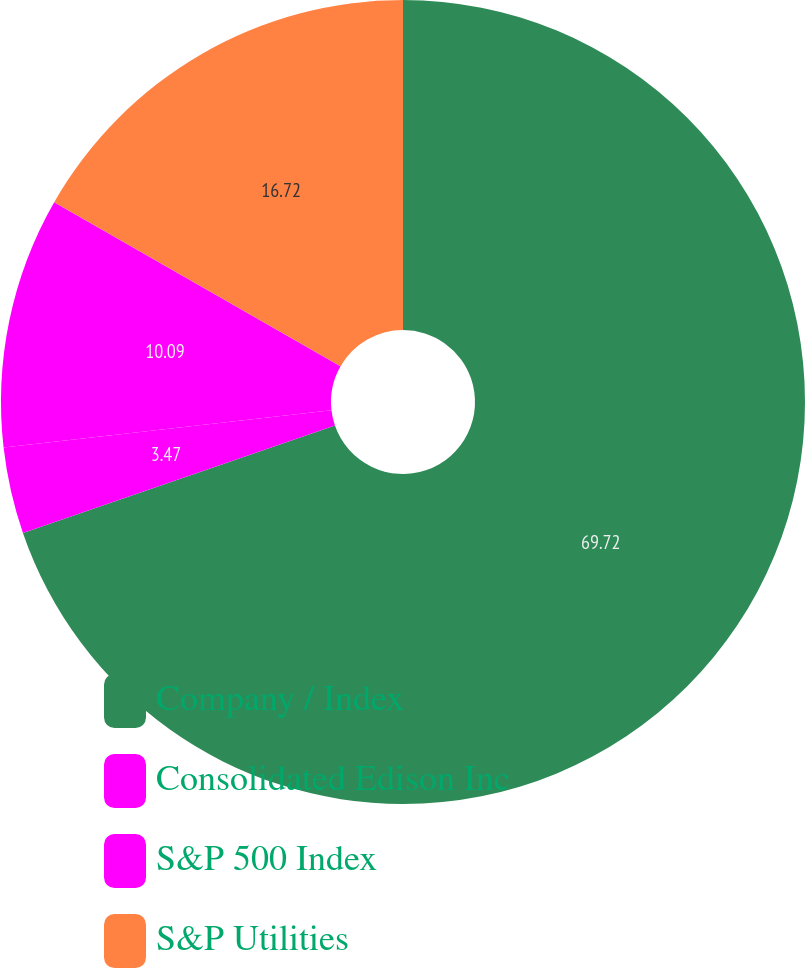Convert chart. <chart><loc_0><loc_0><loc_500><loc_500><pie_chart><fcel>Company / Index<fcel>Consolidated Edison Inc<fcel>S&P 500 Index<fcel>S&P Utilities<nl><fcel>69.72%<fcel>3.47%<fcel>10.09%<fcel>16.72%<nl></chart> 